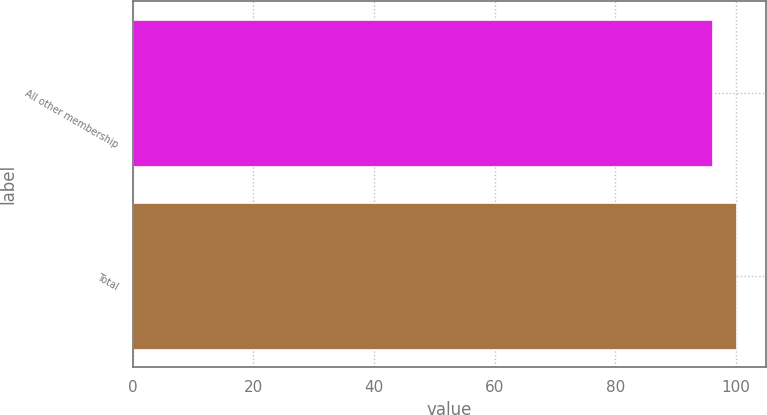Convert chart. <chart><loc_0><loc_0><loc_500><loc_500><bar_chart><fcel>All other membership<fcel>Total<nl><fcel>96.1<fcel>100<nl></chart> 